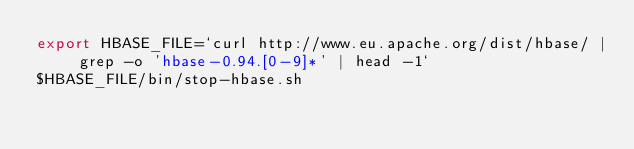<code> <loc_0><loc_0><loc_500><loc_500><_Bash_>export HBASE_FILE=`curl http://www.eu.apache.org/dist/hbase/ | grep -o 'hbase-0.94.[0-9]*' | head -1`
$HBASE_FILE/bin/stop-hbase.sh
</code> 